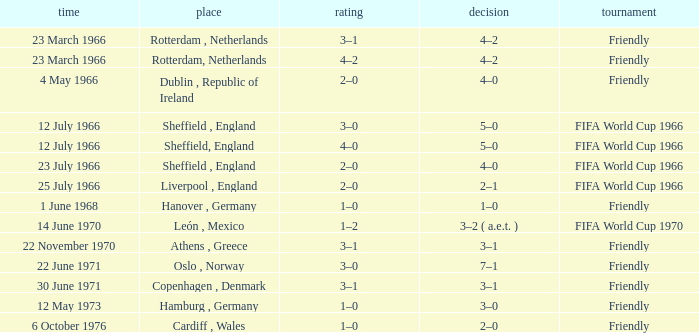Which result's venue was in Rotterdam, Netherlands? 4–2, 4–2. 